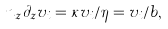<formula> <loc_0><loc_0><loc_500><loc_500>n _ { z } \partial _ { z } v _ { i } = \kappa v _ { i } / \eta = v _ { i } / b ,</formula> 